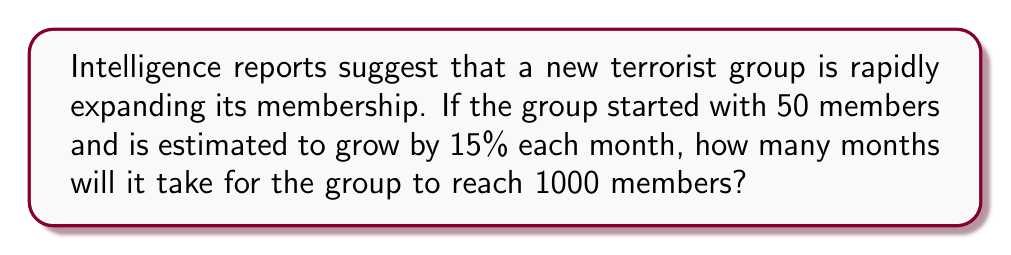Can you answer this question? Let's approach this step-by-step using an exponential growth model:

1) The exponential growth formula is:
   $$A = P(1 + r)^t$$
   where A is the final amount, P is the initial amount, r is the growth rate, and t is the time.

2) We know:
   P = 50 (initial members)
   r = 0.15 (15% growth rate)
   A = 1000 (target membership)

3) Plugging these into our formula:
   $$1000 = 50(1 + 0.15)^t$$

4) Dividing both sides by 50:
   $$20 = (1.15)^t$$

5) To solve for t, we need to use logarithms. Taking the natural log of both sides:
   $$\ln(20) = t \cdot \ln(1.15)$$

6) Solving for t:
   $$t = \frac{\ln(20)}{\ln(1.15)}$$

7) Using a calculator:
   $$t \approx 20.0236$$

8) Since we can't have a fractional month in this context, we round up to the next whole number.
Answer: 21 months 